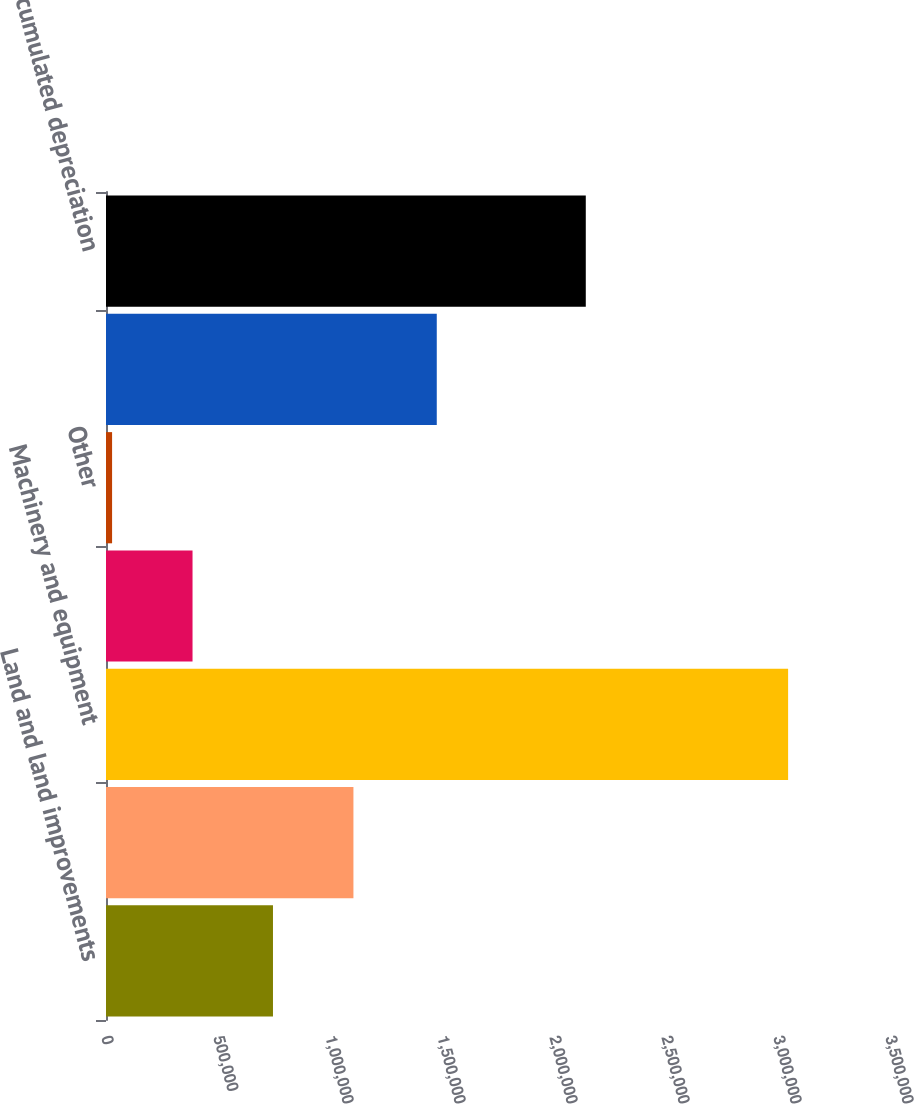<chart> <loc_0><loc_0><loc_500><loc_500><bar_chart><fcel>Land and land improvements<fcel>Buildings<fcel>Machinery and equipment<fcel>Construction in progress<fcel>Other<fcel>Property plant and equipment<fcel>Less accumulated depreciation<nl><fcel>745448<fcel>1.10459e+06<fcel>3.04514e+06<fcel>386309<fcel>27170<fcel>1.47665e+06<fcel>2.14191e+06<nl></chart> 